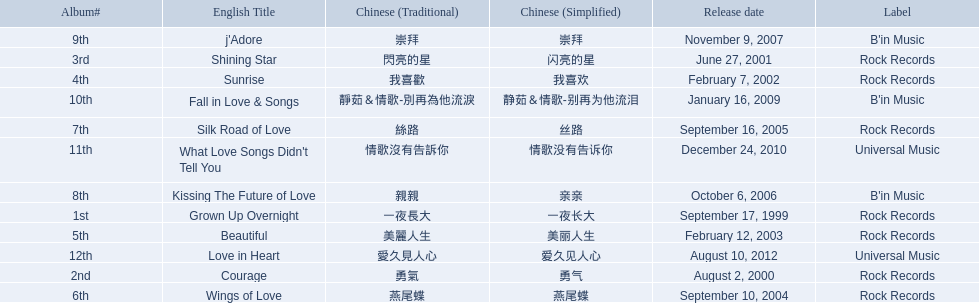Which songs did b'in music produce? Kissing The Future of Love, j'Adore, Fall in Love & Songs. Which one was released in an even numbered year? Kissing The Future of Love. 